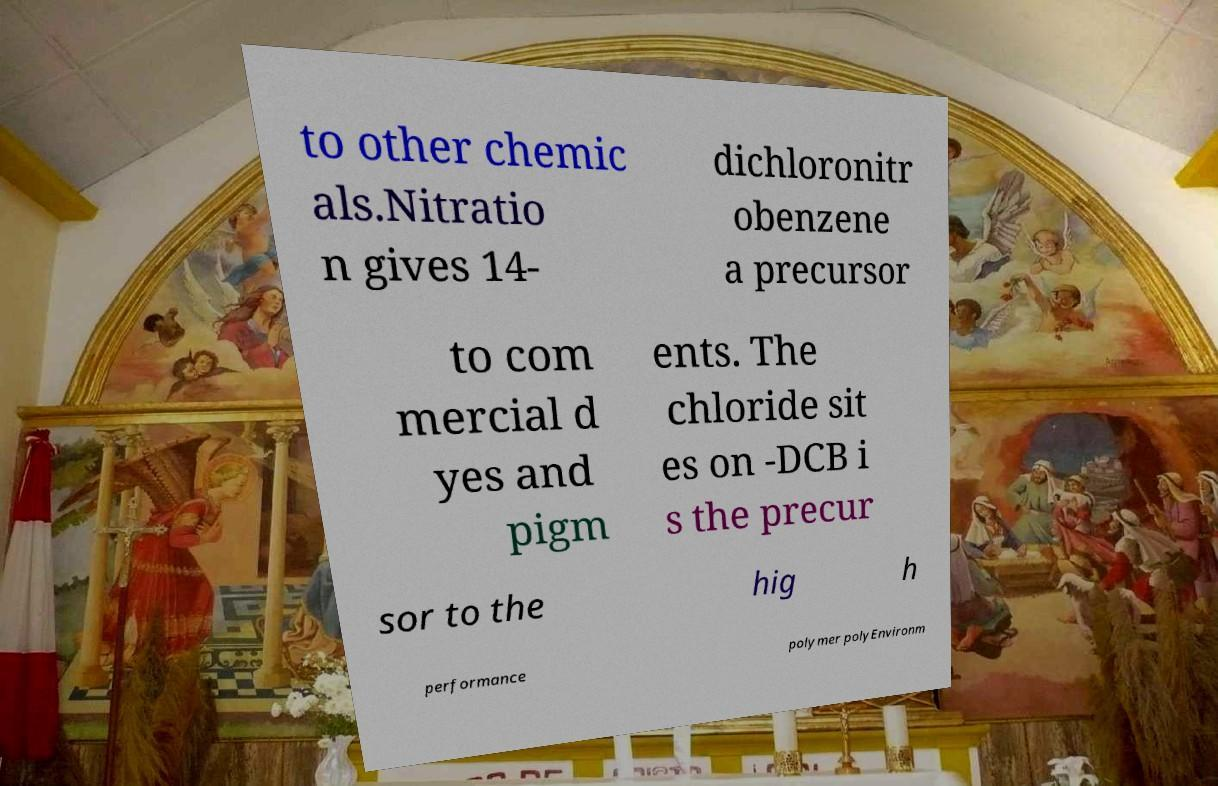Please read and relay the text visible in this image. What does it say? to other chemic als.Nitratio n gives 14- dichloronitr obenzene a precursor to com mercial d yes and pigm ents. The chloride sit es on -DCB i s the precur sor to the hig h performance polymer polyEnvironm 